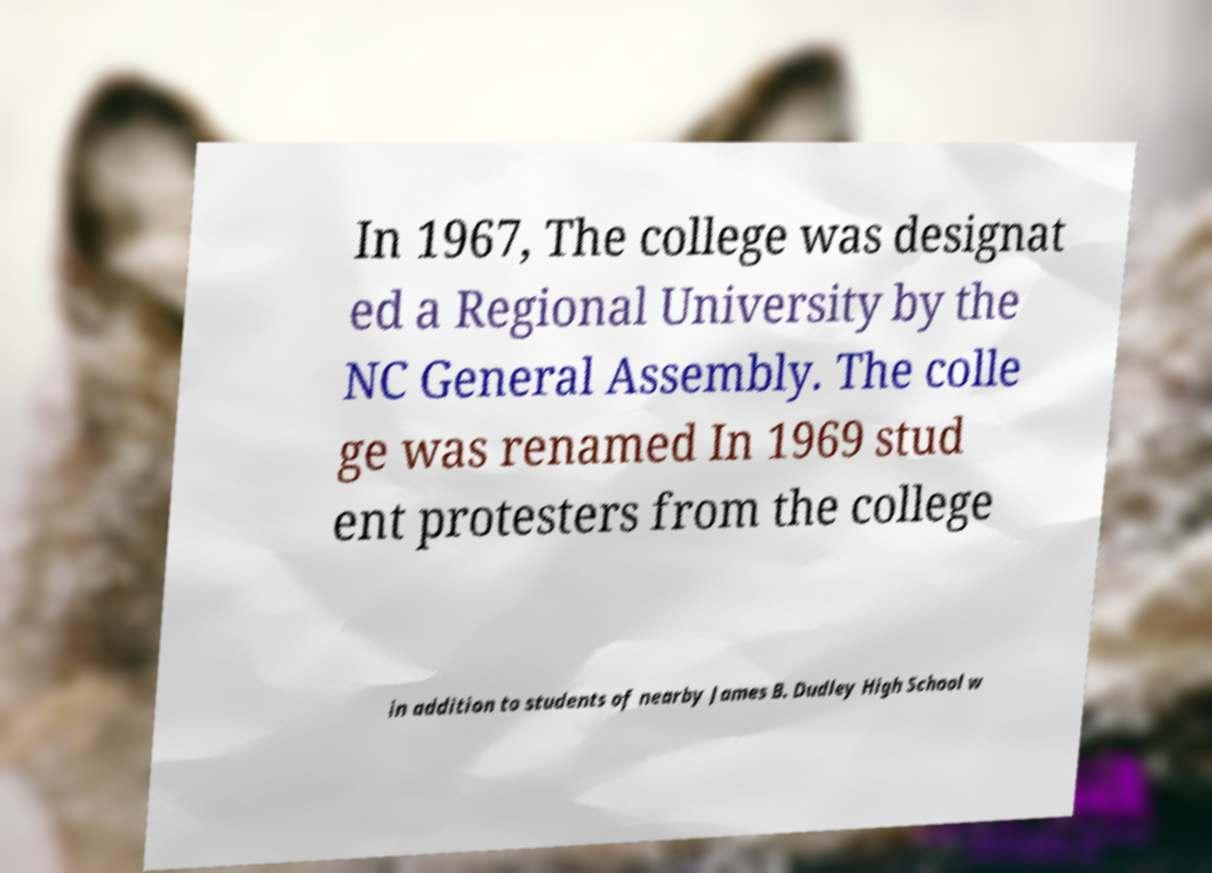For documentation purposes, I need the text within this image transcribed. Could you provide that? In 1967, The college was designat ed a Regional University by the NC General Assembly. The colle ge was renamed In 1969 stud ent protesters from the college in addition to students of nearby James B. Dudley High School w 